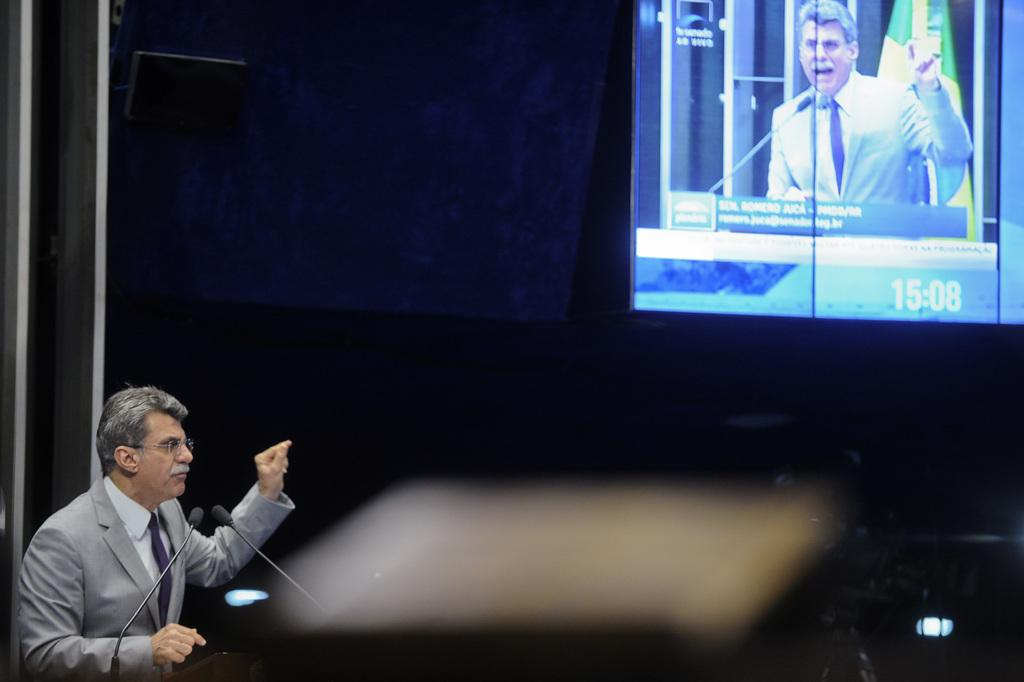Provide a one-sentence caption for the provided image. A man is giving a speech and pointing toward a screen which shows the time 15:08. 